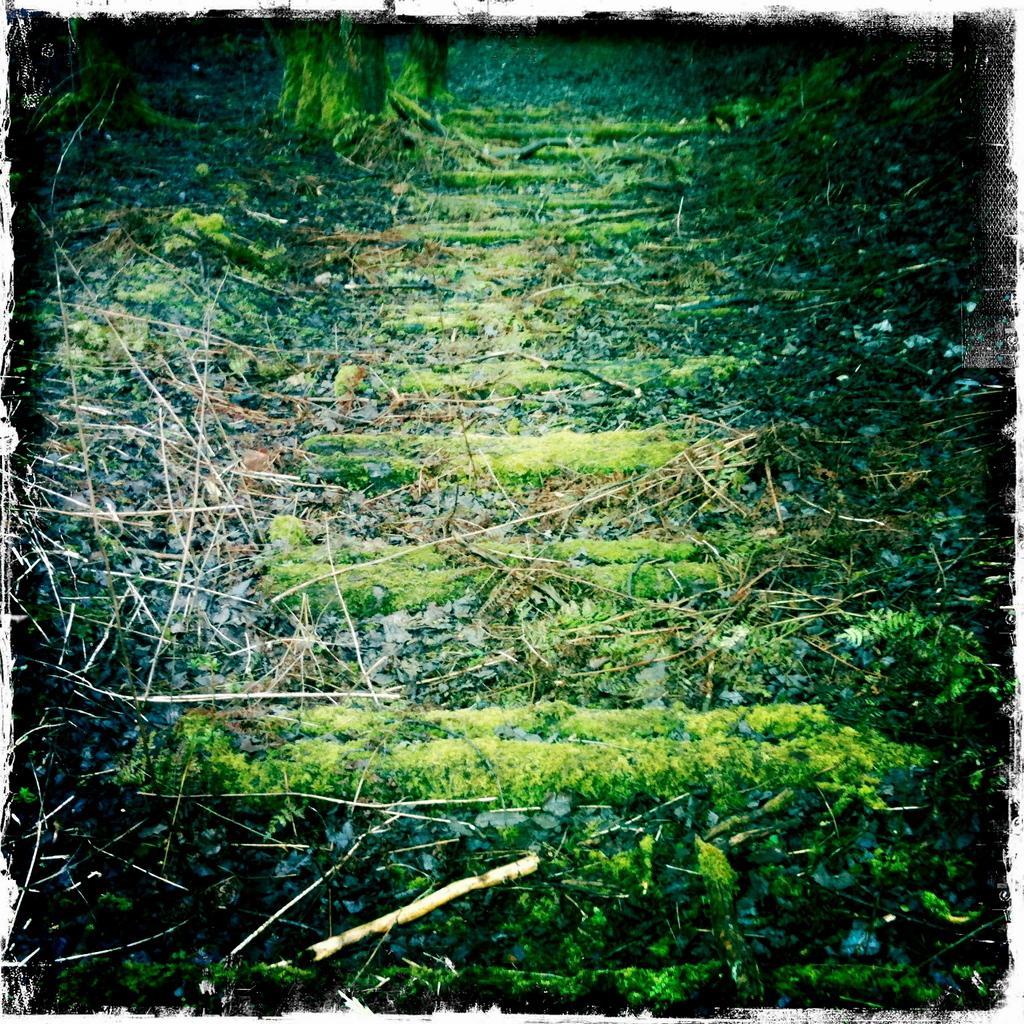Could you give a brief overview of what you see in this image? This picture is full of greenery. 